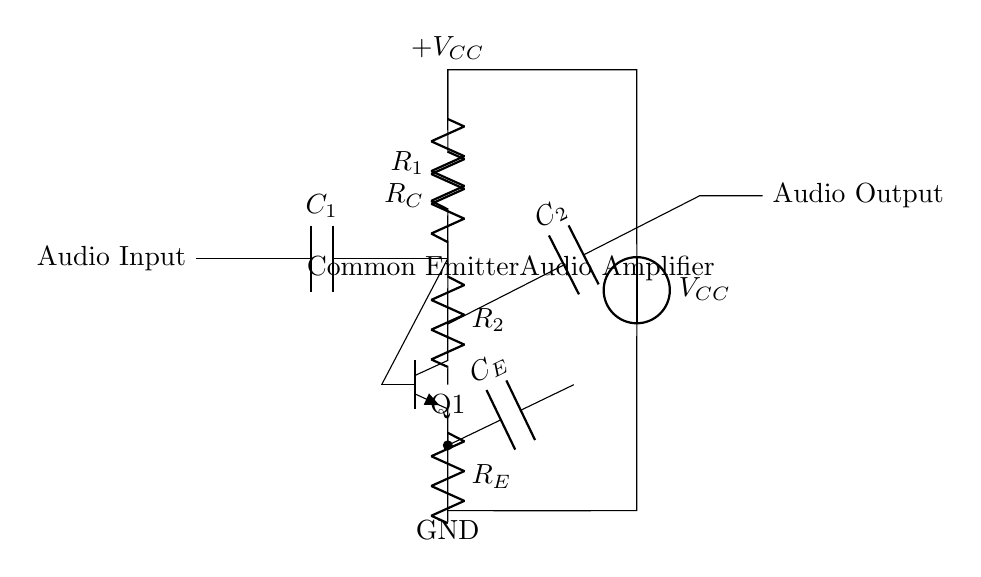What is the type of amplifier shown? The circuit depicts a common emitter amplifier, indicated by the arrangement of the transistor and the configuration of the passive components.
Answer: common emitter What is the value of the biasing resistor labeled R1? The value of R1 is defined within the circuit diagram; however, it does not have a numerical designation shown explicitly here. The primary function is to provide biasing to the transistor.
Answer: not specified How many capacitors are included in this circuit? There are two capacitors in the circuit, denoted as C1 and C2, which serve to couple the audio signals and filter DC voltages.
Answer: 2 What is the purpose of R_E in the circuit? R_E, the emitter resistor, is used to stabilize the operating point of the transistor and improve linearity of the amplifier, providing feedback against variations in current.
Answer: stabilizing What would happen if C1 is removed from the circuit? If C1 is removed, the DC component of the audio input signal would directly affect the biasing of the transistor, potentially leading to distortion or improper operation of the amplifier.
Answer: distortion What does V_CC represent in the circuit? V_CC is the supply voltage for the circuit, indicating the potential difference applied to the collector of the transistor, powering the amplifier.
Answer: supply voltage What role does R_C play in the amplification process? R_C, the collector resistor, helps control the gain of the amplifier by setting the output impedance and affecting the voltage drop across the collector-emitter junction of the transistor.
Answer: gain control 